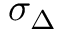Convert formula to latex. <formula><loc_0><loc_0><loc_500><loc_500>\sigma _ { \Delta }</formula> 